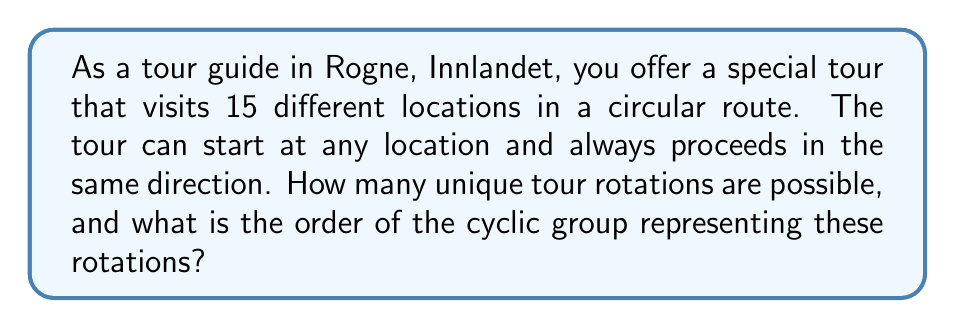What is the answer to this math problem? To solve this problem, we need to understand the concept of cyclic groups and how they relate to rotations.

1. In this scenario, each rotation of the tour represents an element in the cyclic group.

2. The number of unique rotations is equal to the number of locations in the tour, which is 15.

3. We can represent each rotation as a power of a generator $g$, where $g$ represents a single step rotation:

   $\{e, g, g^2, g^3, ..., g^{14}\}$

   Here, $e$ represents the identity element (no rotation).

4. The order of a cyclic group is the number of unique elements in the group.

5. In this case, the order of the group is 15, because after 15 rotations, we return to the starting position:

   $g^{15} = e$

6. This group is isomorphic to the additive group of integers modulo 15, denoted as $\mathbb{Z}_{15}$.

7. The order of any element in a finite cyclic group divides the order of the group. In this case, all elements (except the identity) have order 15.

Therefore, the cyclic group representing the tour rotations has 15 elements and an order of 15.
Answer: The cyclic group representing the tour rotations has an order of 15. 